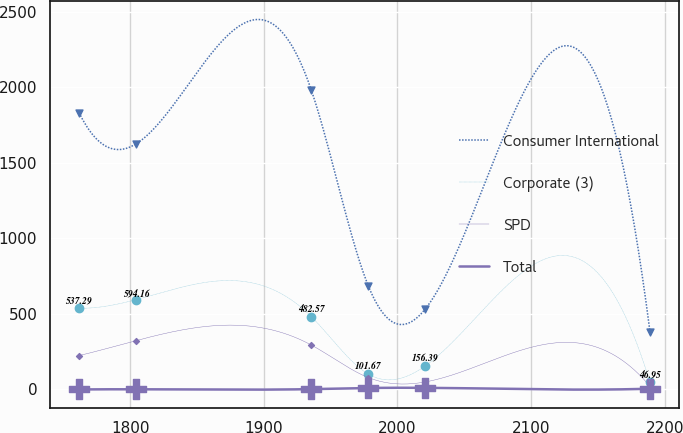Convert chart. <chart><loc_0><loc_0><loc_500><loc_500><line_chart><ecel><fcel>Consumer International<fcel>Corporate (3)<fcel>SPD<fcel>Total<nl><fcel>1761.83<fcel>1830.58<fcel>537.29<fcel>223.99<fcel>0<nl><fcel>1804.53<fcel>1624.94<fcel>594.16<fcel>323.17<fcel>1.06<nl><fcel>1935.48<fcel>1982.55<fcel>482.57<fcel>294.25<fcel>2.12<nl><fcel>1978.18<fcel>685.33<fcel>101.67<fcel>78.75<fcel>9.62<nl><fcel>2020.88<fcel>533.36<fcel>156.39<fcel>49.84<fcel>10.68<nl><fcel>2188.88<fcel>381.39<fcel>46.95<fcel>20.93<fcel>4.96<nl></chart> 